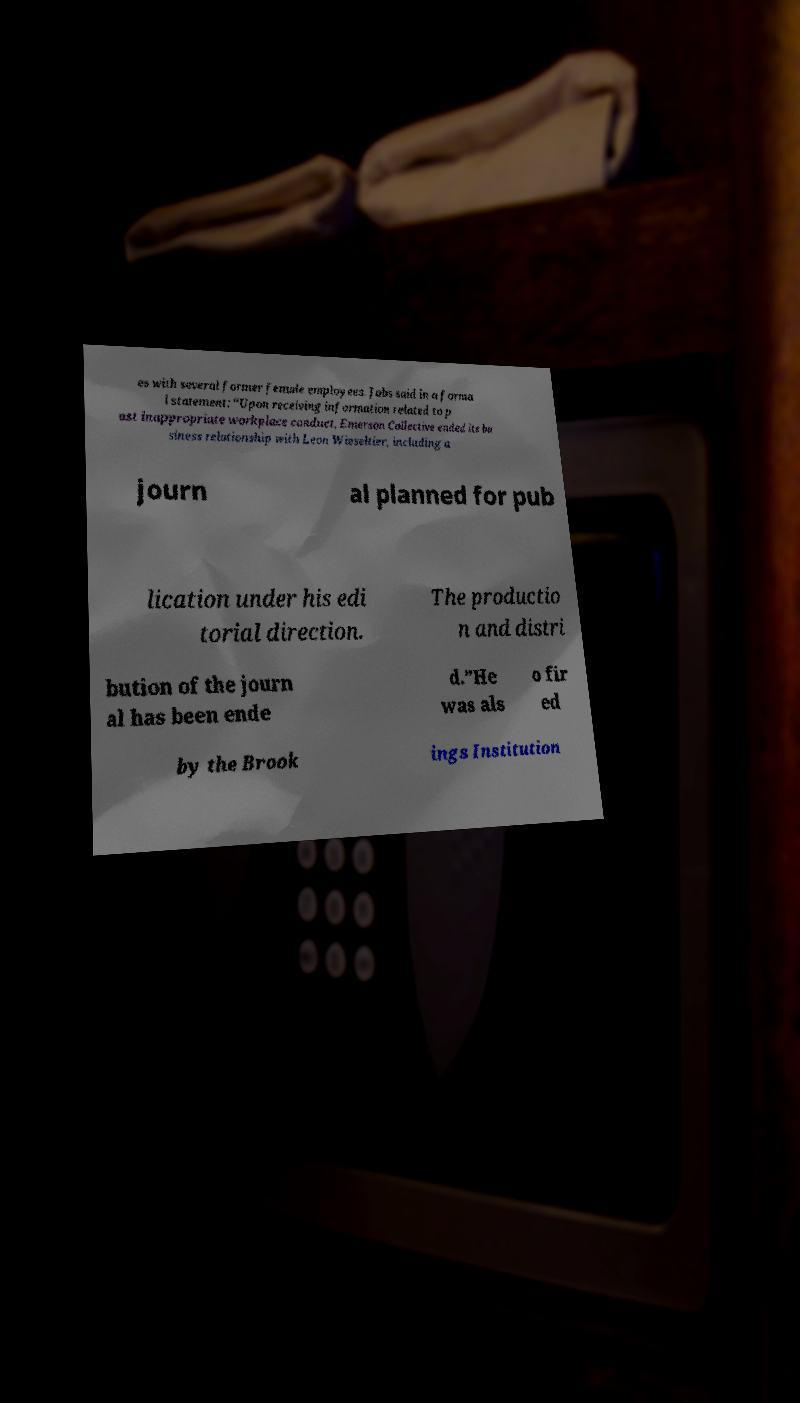Could you assist in decoding the text presented in this image and type it out clearly? es with several former female employees. Jobs said in a forma l statement: “Upon receiving information related to p ast inappropriate workplace conduct, Emerson Collective ended its bu siness relationship with Leon Wieseltier, including a journ al planned for pub lication under his edi torial direction. The productio n and distri bution of the journ al has been ende d.”He was als o fir ed by the Brook ings Institution 